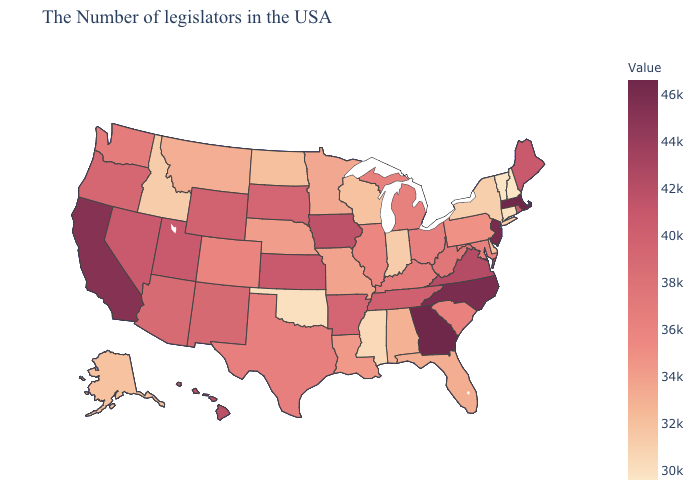Among the states that border Connecticut , does Massachusetts have the highest value?
Write a very short answer. Yes. Which states hav the highest value in the South?
Quick response, please. Georgia. Which states hav the highest value in the MidWest?
Write a very short answer. Iowa. Does Massachusetts have the highest value in the USA?
Quick response, please. Yes. Which states hav the highest value in the West?
Keep it brief. California. 